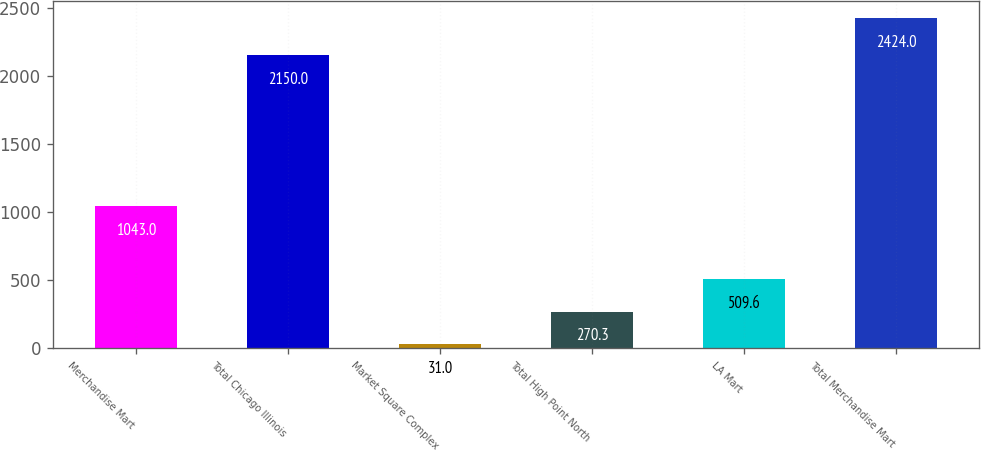Convert chart to OTSL. <chart><loc_0><loc_0><loc_500><loc_500><bar_chart><fcel>Merchandise Mart<fcel>Total Chicago Illinois<fcel>Market Square Complex<fcel>Total High Point North<fcel>LA Mart<fcel>Total Merchandise Mart<nl><fcel>1043<fcel>2150<fcel>31<fcel>270.3<fcel>509.6<fcel>2424<nl></chart> 